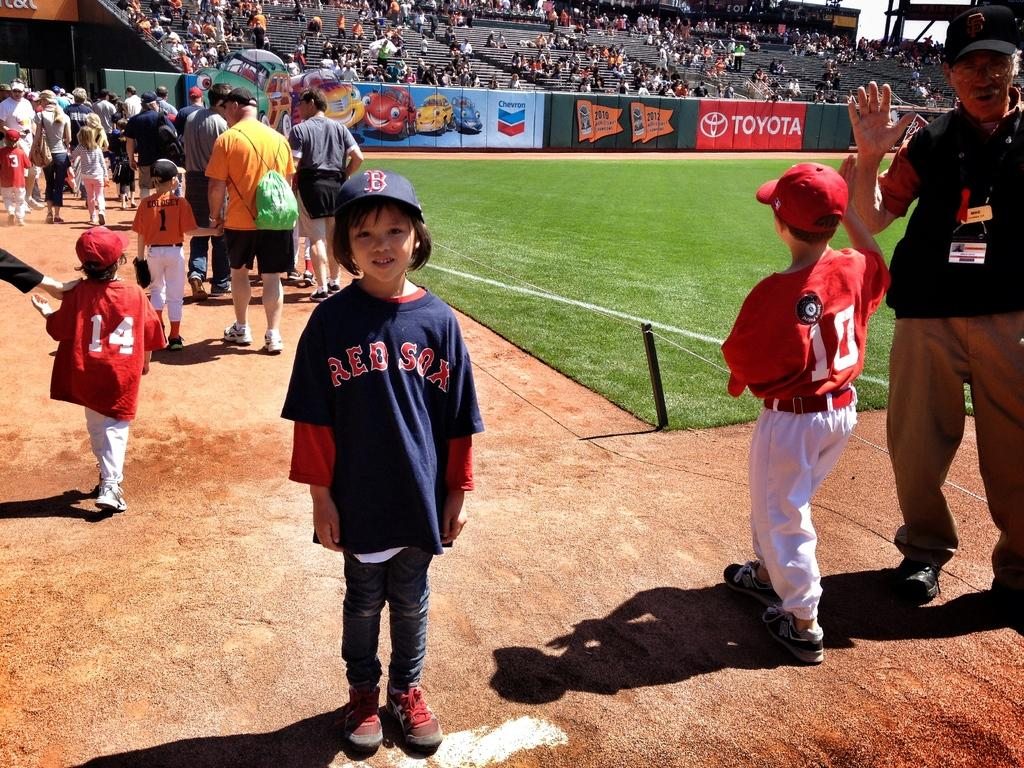<image>
Write a terse but informative summary of the picture. A young Red Sox fan stands in the bullpen. 